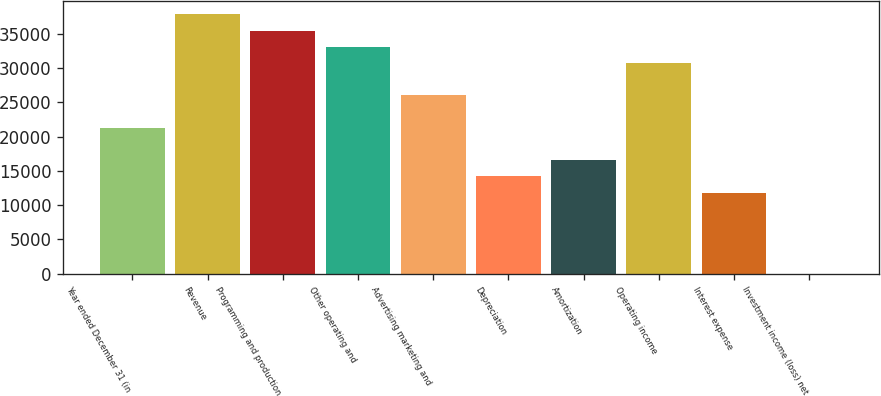Convert chart. <chart><loc_0><loc_0><loc_500><loc_500><bar_chart><fcel>Year ended December 31 (in<fcel>Revenue<fcel>Programming and production<fcel>Other operating and<fcel>Advertising marketing and<fcel>Depreciation<fcel>Amortization<fcel>Operating income<fcel>Interest expense<fcel>Investment income (loss) net<nl><fcel>21286.7<fcel>37829.8<fcel>35466.5<fcel>33103.2<fcel>26013.3<fcel>14196.8<fcel>16560.1<fcel>30739.9<fcel>11833.5<fcel>17<nl></chart> 